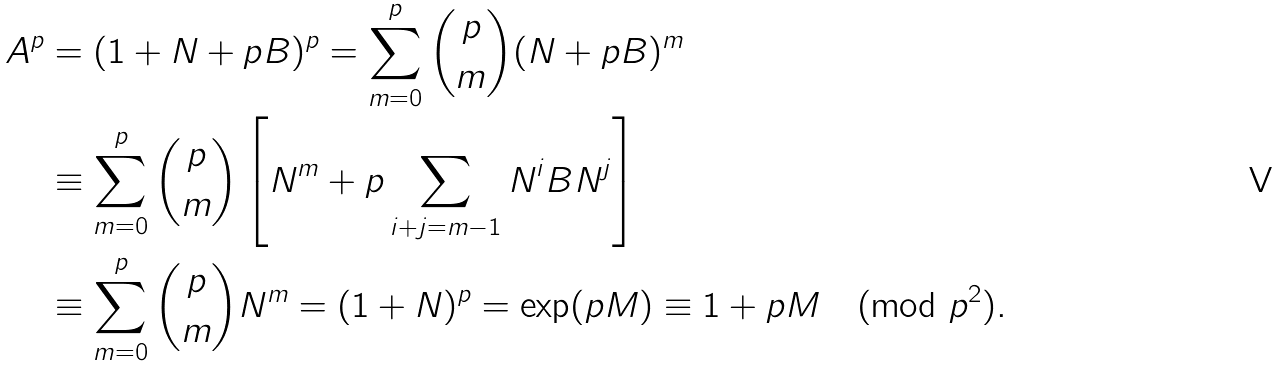Convert formula to latex. <formula><loc_0><loc_0><loc_500><loc_500>A ^ { p } & = ( 1 + N + p B ) ^ { p } = \sum _ { m = 0 } ^ { p } \binom { p } { m } ( N + p B ) ^ { m } \\ & \equiv \sum _ { m = 0 } ^ { p } \binom { p } { m } \left [ N ^ { m } + p \sum _ { i + j = m - 1 } N ^ { i } B N ^ { j } \right ] \\ & \equiv \sum _ { m = 0 } ^ { p } \binom { p } { m } N ^ { m } = ( 1 + N ) ^ { p } = \exp ( p M ) \equiv 1 + p M \pmod { p ^ { 2 } } .</formula> 